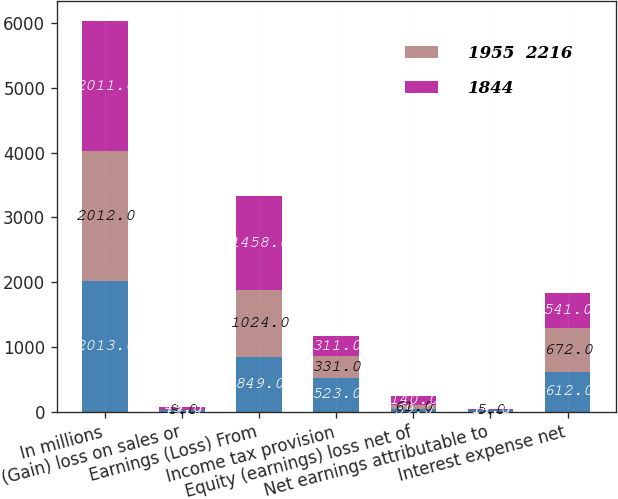<chart> <loc_0><loc_0><loc_500><loc_500><stacked_bar_chart><ecel><fcel>In millions<fcel>(Gain) loss on sales or<fcel>Earnings (Loss) From<fcel>Income tax provision<fcel>Equity (earnings) loss net of<fcel>Net earnings attributable to<fcel>Interest expense net<nl><fcel>nan<fcel>2013<fcel>19<fcel>849<fcel>523<fcel>39<fcel>17<fcel>612<nl><fcel>1955  2216<fcel>2012<fcel>9<fcel>1024<fcel>331<fcel>61<fcel>5<fcel>672<nl><fcel>1844<fcel>2011<fcel>49<fcel>1458<fcel>311<fcel>140<fcel>14<fcel>541<nl></chart> 